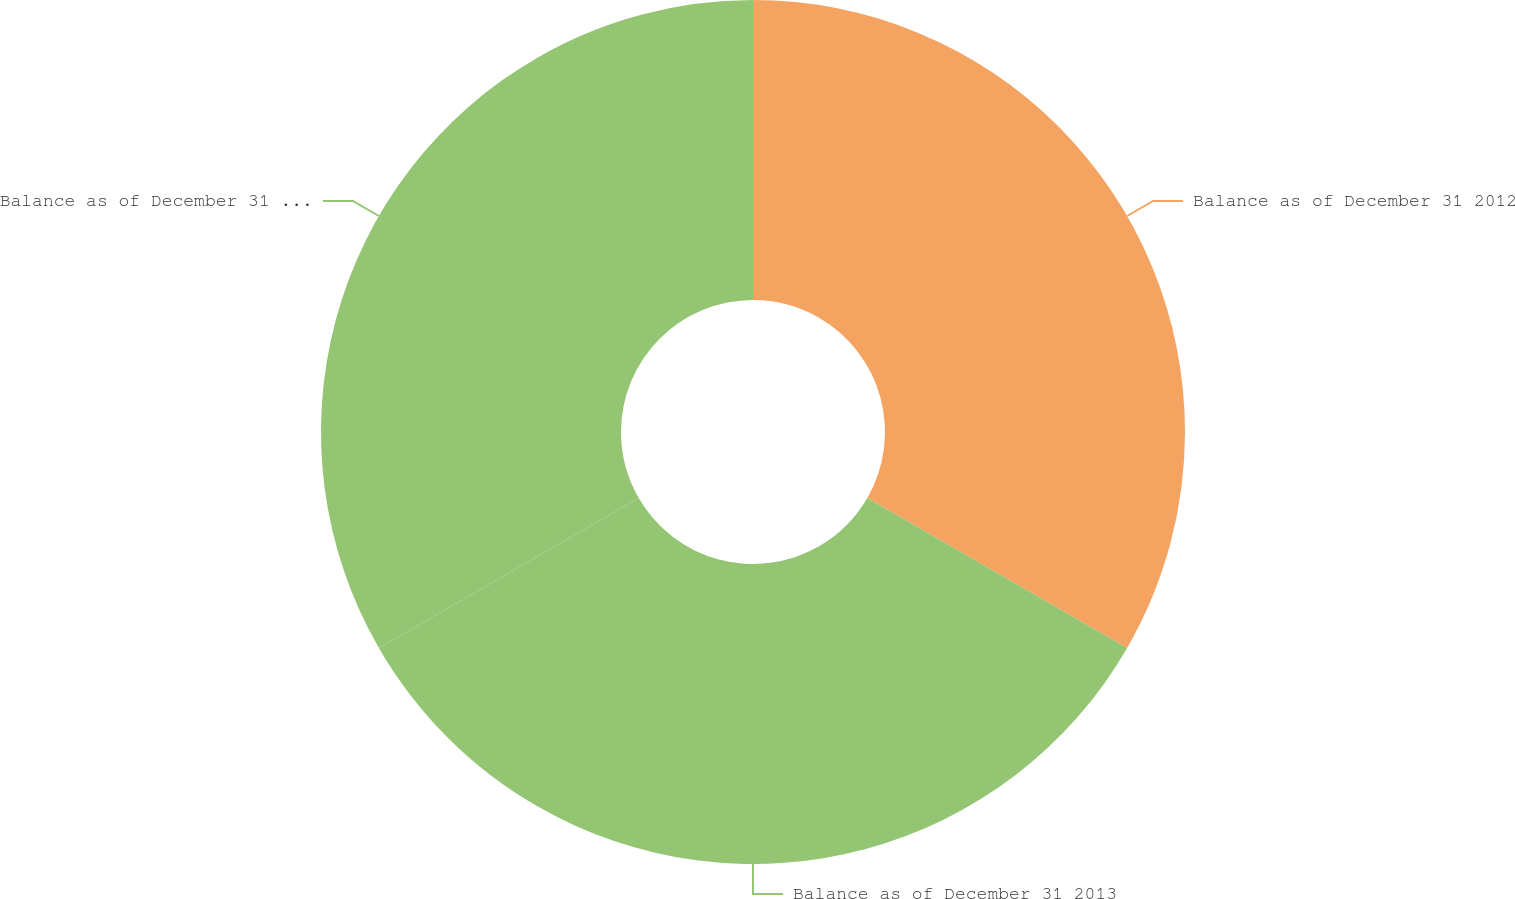Convert chart. <chart><loc_0><loc_0><loc_500><loc_500><pie_chart><fcel>Balance as of December 31 2012<fcel>Balance as of December 31 2013<fcel>Balance as of December 31 2014<nl><fcel>33.33%<fcel>33.33%<fcel>33.33%<nl></chart> 